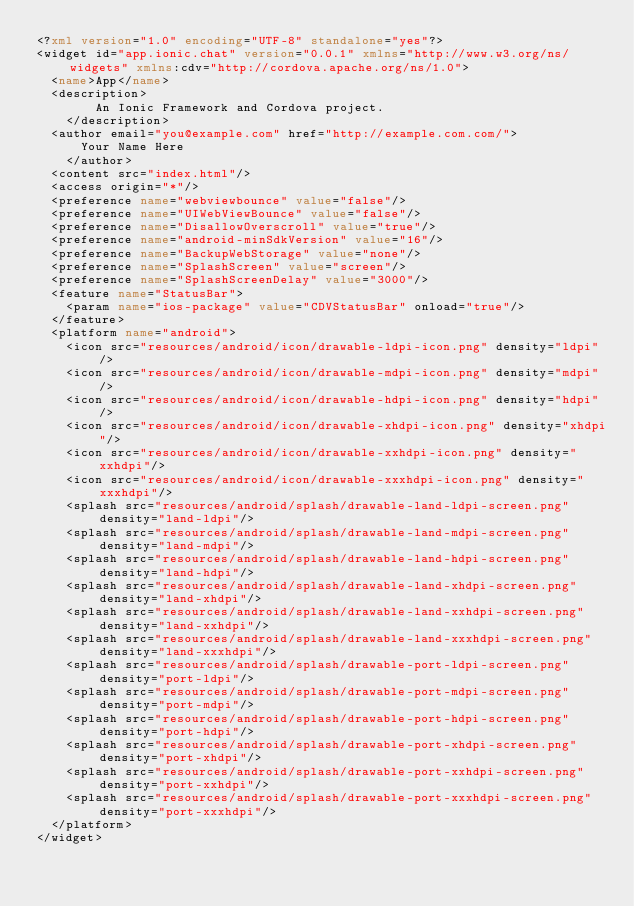Convert code to text. <code><loc_0><loc_0><loc_500><loc_500><_XML_><?xml version="1.0" encoding="UTF-8" standalone="yes"?>
<widget id="app.ionic.chat" version="0.0.1" xmlns="http://www.w3.org/ns/widgets" xmlns:cdv="http://cordova.apache.org/ns/1.0">
  <name>App</name>
  <description>
        An Ionic Framework and Cordova project.
    </description>
  <author email="you@example.com" href="http://example.com.com/">
      Your Name Here
    </author>
  <content src="index.html"/>
  <access origin="*"/>
  <preference name="webviewbounce" value="false"/>
  <preference name="UIWebViewBounce" value="false"/>
  <preference name="DisallowOverscroll" value="true"/>
  <preference name="android-minSdkVersion" value="16"/>
  <preference name="BackupWebStorage" value="none"/>
  <preference name="SplashScreen" value="screen"/>
  <preference name="SplashScreenDelay" value="3000"/>
  <feature name="StatusBar">
    <param name="ios-package" value="CDVStatusBar" onload="true"/>
  </feature>
  <platform name="android">
    <icon src="resources/android/icon/drawable-ldpi-icon.png" density="ldpi"/>
    <icon src="resources/android/icon/drawable-mdpi-icon.png" density="mdpi"/>
    <icon src="resources/android/icon/drawable-hdpi-icon.png" density="hdpi"/>
    <icon src="resources/android/icon/drawable-xhdpi-icon.png" density="xhdpi"/>
    <icon src="resources/android/icon/drawable-xxhdpi-icon.png" density="xxhdpi"/>
    <icon src="resources/android/icon/drawable-xxxhdpi-icon.png" density="xxxhdpi"/>
    <splash src="resources/android/splash/drawable-land-ldpi-screen.png" density="land-ldpi"/>
    <splash src="resources/android/splash/drawable-land-mdpi-screen.png" density="land-mdpi"/>
    <splash src="resources/android/splash/drawable-land-hdpi-screen.png" density="land-hdpi"/>
    <splash src="resources/android/splash/drawable-land-xhdpi-screen.png" density="land-xhdpi"/>
    <splash src="resources/android/splash/drawable-land-xxhdpi-screen.png" density="land-xxhdpi"/>
    <splash src="resources/android/splash/drawable-land-xxxhdpi-screen.png" density="land-xxxhdpi"/>
    <splash src="resources/android/splash/drawable-port-ldpi-screen.png" density="port-ldpi"/>
    <splash src="resources/android/splash/drawable-port-mdpi-screen.png" density="port-mdpi"/>
    <splash src="resources/android/splash/drawable-port-hdpi-screen.png" density="port-hdpi"/>
    <splash src="resources/android/splash/drawable-port-xhdpi-screen.png" density="port-xhdpi"/>
    <splash src="resources/android/splash/drawable-port-xxhdpi-screen.png" density="port-xxhdpi"/>
    <splash src="resources/android/splash/drawable-port-xxxhdpi-screen.png" density="port-xxxhdpi"/>
  </platform>
</widget></code> 